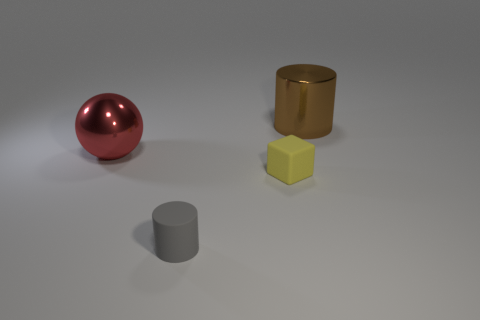Add 4 small gray cylinders. How many objects exist? 8 Subtract all blocks. How many objects are left? 3 Subtract all small blue metal spheres. Subtract all small things. How many objects are left? 2 Add 2 red balls. How many red balls are left? 3 Add 3 big red metal objects. How many big red metal objects exist? 4 Subtract 0 blue cubes. How many objects are left? 4 